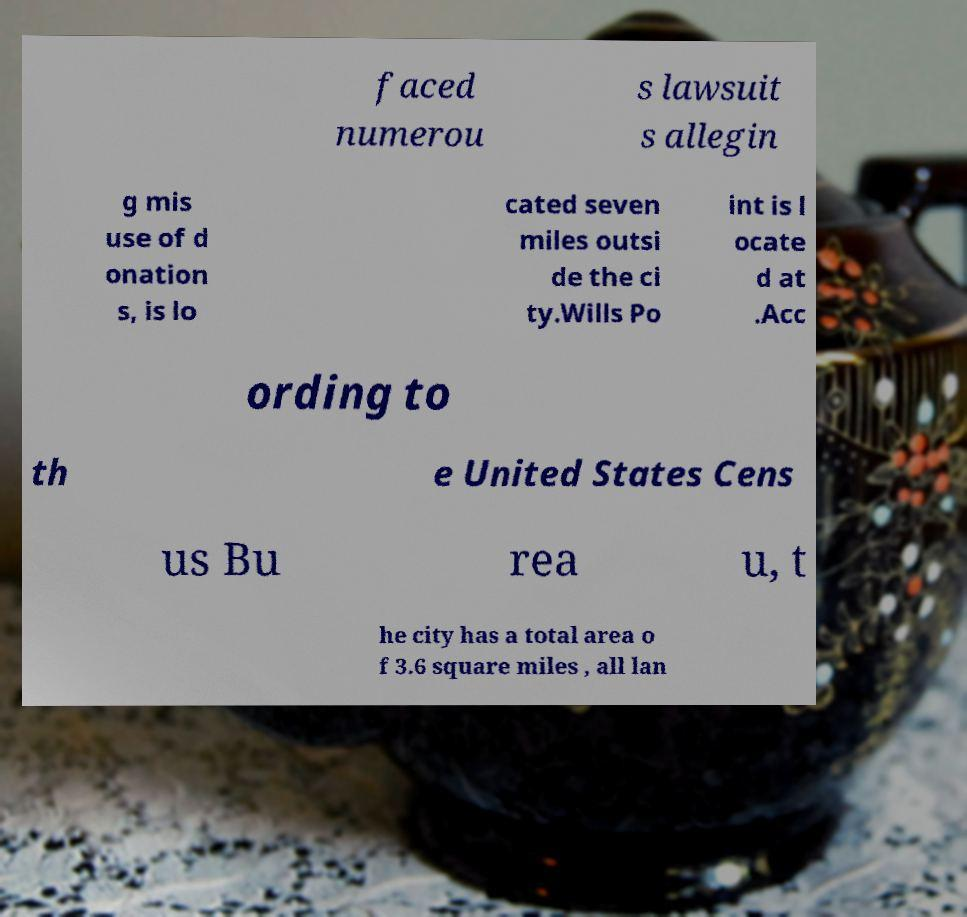Can you read and provide the text displayed in the image?This photo seems to have some interesting text. Can you extract and type it out for me? faced numerou s lawsuit s allegin g mis use of d onation s, is lo cated seven miles outsi de the ci ty.Wills Po int is l ocate d at .Acc ording to th e United States Cens us Bu rea u, t he city has a total area o f 3.6 square miles , all lan 